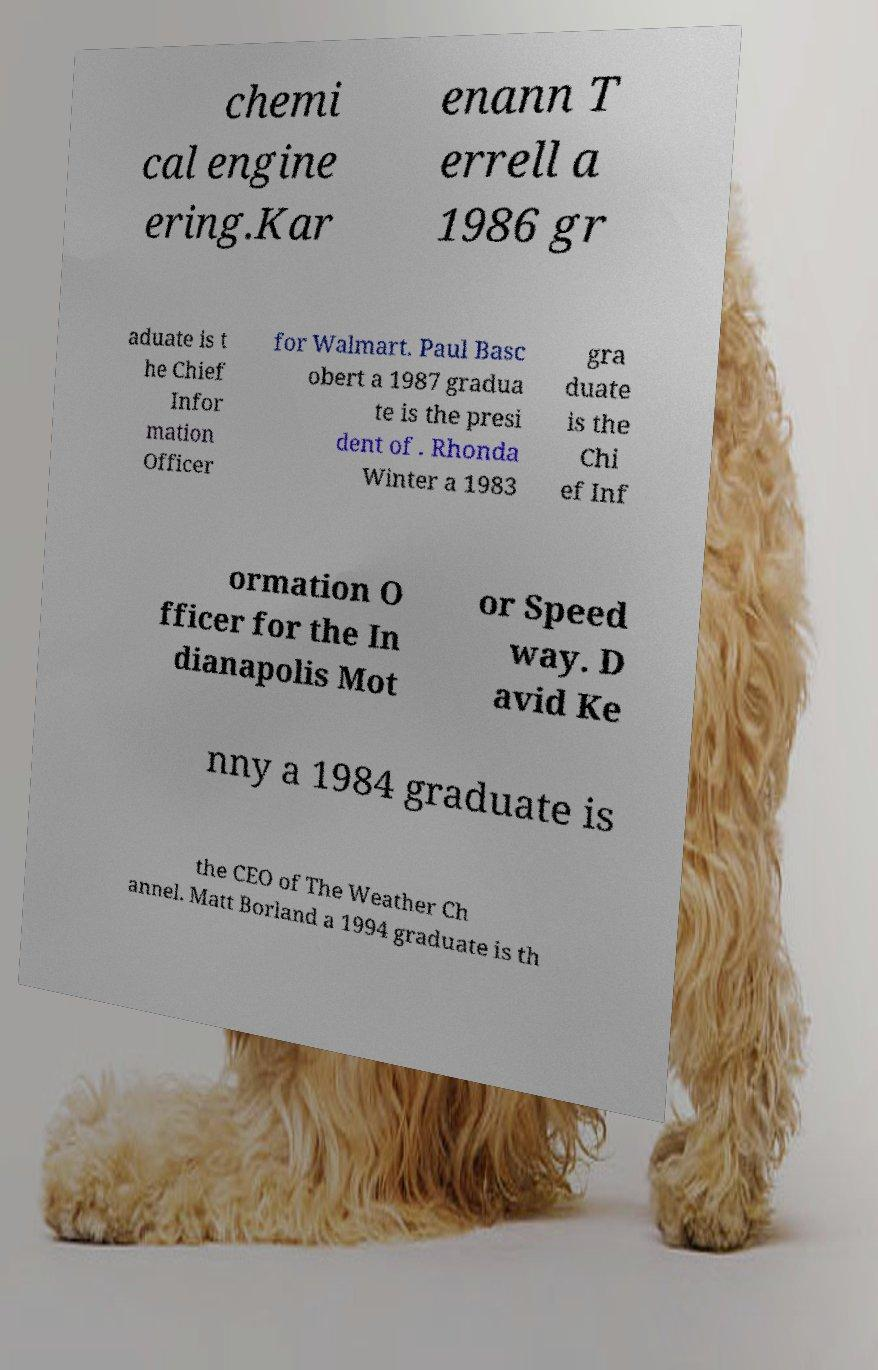Can you read and provide the text displayed in the image?This photo seems to have some interesting text. Can you extract and type it out for me? chemi cal engine ering.Kar enann T errell a 1986 gr aduate is t he Chief Infor mation Officer for Walmart. Paul Basc obert a 1987 gradua te is the presi dent of . Rhonda Winter a 1983 gra duate is the Chi ef Inf ormation O fficer for the In dianapolis Mot or Speed way. D avid Ke nny a 1984 graduate is the CEO of The Weather Ch annel. Matt Borland a 1994 graduate is th 